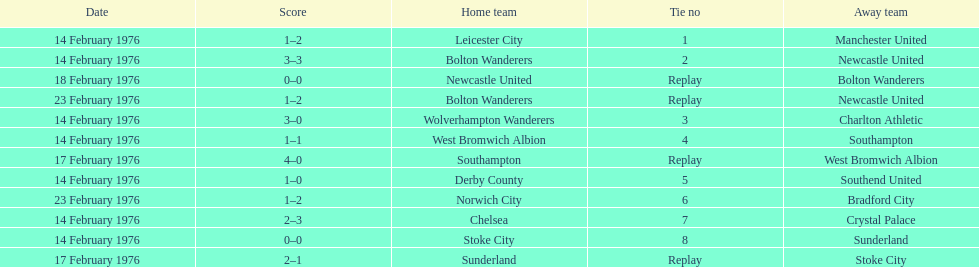How many games played by sunderland are listed here? 2. 